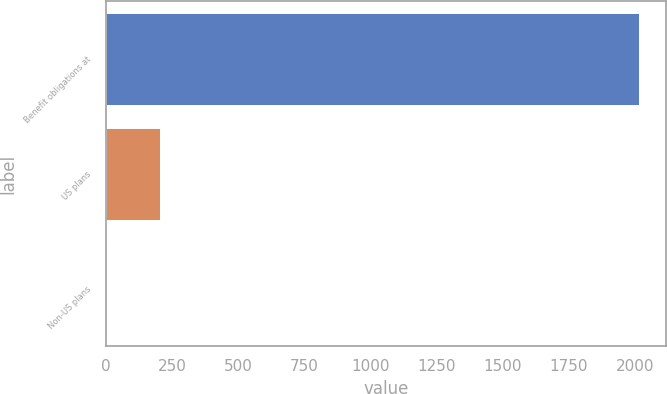Convert chart. <chart><loc_0><loc_0><loc_500><loc_500><bar_chart><fcel>Benefit obligations at<fcel>US plans<fcel>Non-US plans<nl><fcel>2016<fcel>203.94<fcel>2.6<nl></chart> 